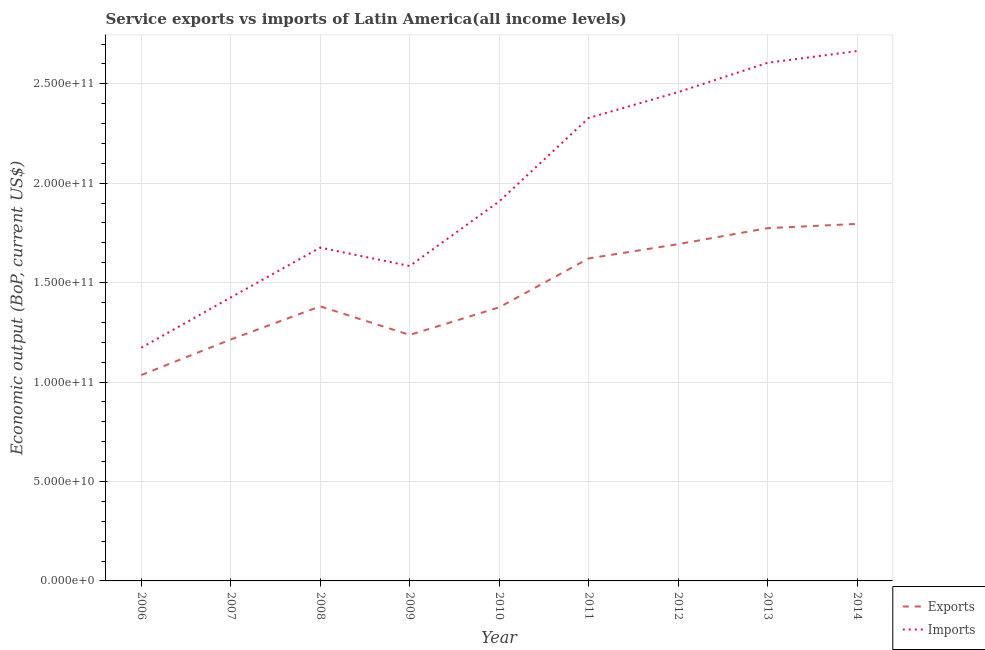Does the line corresponding to amount of service imports intersect with the line corresponding to amount of service exports?
Make the answer very short. No. Is the number of lines equal to the number of legend labels?
Provide a short and direct response. Yes. What is the amount of service imports in 2008?
Your answer should be compact. 1.68e+11. Across all years, what is the maximum amount of service exports?
Make the answer very short. 1.80e+11. Across all years, what is the minimum amount of service exports?
Give a very brief answer. 1.04e+11. In which year was the amount of service exports minimum?
Ensure brevity in your answer.  2006. What is the total amount of service imports in the graph?
Your answer should be very brief. 1.78e+12. What is the difference between the amount of service exports in 2010 and that in 2013?
Make the answer very short. -3.98e+1. What is the difference between the amount of service imports in 2010 and the amount of service exports in 2007?
Give a very brief answer. 6.94e+1. What is the average amount of service exports per year?
Offer a very short reply. 1.46e+11. In the year 2014, what is the difference between the amount of service imports and amount of service exports?
Offer a terse response. 8.69e+1. What is the ratio of the amount of service imports in 2009 to that in 2014?
Your answer should be very brief. 0.59. Is the difference between the amount of service exports in 2009 and 2010 greater than the difference between the amount of service imports in 2009 and 2010?
Provide a short and direct response. Yes. What is the difference between the highest and the second highest amount of service imports?
Your response must be concise. 5.91e+09. What is the difference between the highest and the lowest amount of service exports?
Keep it short and to the point. 7.60e+1. Is the sum of the amount of service imports in 2008 and 2012 greater than the maximum amount of service exports across all years?
Ensure brevity in your answer.  Yes. Does the amount of service imports monotonically increase over the years?
Give a very brief answer. No. How many lines are there?
Keep it short and to the point. 2. Does the graph contain any zero values?
Your answer should be compact. No. Does the graph contain grids?
Ensure brevity in your answer.  Yes. Where does the legend appear in the graph?
Keep it short and to the point. Bottom right. How many legend labels are there?
Provide a succinct answer. 2. What is the title of the graph?
Ensure brevity in your answer.  Service exports vs imports of Latin America(all income levels). What is the label or title of the X-axis?
Your answer should be compact. Year. What is the label or title of the Y-axis?
Keep it short and to the point. Economic output (BoP, current US$). What is the Economic output (BoP, current US$) in Exports in 2006?
Provide a short and direct response. 1.04e+11. What is the Economic output (BoP, current US$) in Imports in 2006?
Give a very brief answer. 1.17e+11. What is the Economic output (BoP, current US$) of Exports in 2007?
Keep it short and to the point. 1.21e+11. What is the Economic output (BoP, current US$) in Imports in 2007?
Your answer should be very brief. 1.43e+11. What is the Economic output (BoP, current US$) in Exports in 2008?
Ensure brevity in your answer.  1.38e+11. What is the Economic output (BoP, current US$) in Imports in 2008?
Provide a succinct answer. 1.68e+11. What is the Economic output (BoP, current US$) in Exports in 2009?
Provide a succinct answer. 1.24e+11. What is the Economic output (BoP, current US$) in Imports in 2009?
Give a very brief answer. 1.58e+11. What is the Economic output (BoP, current US$) of Exports in 2010?
Keep it short and to the point. 1.38e+11. What is the Economic output (BoP, current US$) of Imports in 2010?
Your response must be concise. 1.91e+11. What is the Economic output (BoP, current US$) in Exports in 2011?
Ensure brevity in your answer.  1.62e+11. What is the Economic output (BoP, current US$) in Imports in 2011?
Provide a short and direct response. 2.33e+11. What is the Economic output (BoP, current US$) of Exports in 2012?
Give a very brief answer. 1.69e+11. What is the Economic output (BoP, current US$) of Imports in 2012?
Offer a very short reply. 2.46e+11. What is the Economic output (BoP, current US$) in Exports in 2013?
Offer a very short reply. 1.77e+11. What is the Economic output (BoP, current US$) in Imports in 2013?
Your response must be concise. 2.61e+11. What is the Economic output (BoP, current US$) of Exports in 2014?
Provide a succinct answer. 1.80e+11. What is the Economic output (BoP, current US$) in Imports in 2014?
Give a very brief answer. 2.66e+11. Across all years, what is the maximum Economic output (BoP, current US$) of Exports?
Your answer should be compact. 1.80e+11. Across all years, what is the maximum Economic output (BoP, current US$) in Imports?
Provide a short and direct response. 2.66e+11. Across all years, what is the minimum Economic output (BoP, current US$) in Exports?
Make the answer very short. 1.04e+11. Across all years, what is the minimum Economic output (BoP, current US$) of Imports?
Ensure brevity in your answer.  1.17e+11. What is the total Economic output (BoP, current US$) in Exports in the graph?
Keep it short and to the point. 1.31e+12. What is the total Economic output (BoP, current US$) of Imports in the graph?
Give a very brief answer. 1.78e+12. What is the difference between the Economic output (BoP, current US$) of Exports in 2006 and that in 2007?
Make the answer very short. -1.79e+1. What is the difference between the Economic output (BoP, current US$) of Imports in 2006 and that in 2007?
Offer a terse response. -2.53e+1. What is the difference between the Economic output (BoP, current US$) in Exports in 2006 and that in 2008?
Provide a short and direct response. -3.45e+1. What is the difference between the Economic output (BoP, current US$) in Imports in 2006 and that in 2008?
Ensure brevity in your answer.  -5.04e+1. What is the difference between the Economic output (BoP, current US$) of Exports in 2006 and that in 2009?
Your answer should be compact. -2.02e+1. What is the difference between the Economic output (BoP, current US$) in Imports in 2006 and that in 2009?
Your answer should be very brief. -4.11e+1. What is the difference between the Economic output (BoP, current US$) in Exports in 2006 and that in 2010?
Offer a terse response. -3.40e+1. What is the difference between the Economic output (BoP, current US$) of Imports in 2006 and that in 2010?
Offer a very short reply. -7.36e+1. What is the difference between the Economic output (BoP, current US$) in Exports in 2006 and that in 2011?
Your response must be concise. -5.86e+1. What is the difference between the Economic output (BoP, current US$) of Imports in 2006 and that in 2011?
Offer a very short reply. -1.16e+11. What is the difference between the Economic output (BoP, current US$) of Exports in 2006 and that in 2012?
Your response must be concise. -6.58e+1. What is the difference between the Economic output (BoP, current US$) of Imports in 2006 and that in 2012?
Your answer should be compact. -1.29e+11. What is the difference between the Economic output (BoP, current US$) in Exports in 2006 and that in 2013?
Give a very brief answer. -7.39e+1. What is the difference between the Economic output (BoP, current US$) of Imports in 2006 and that in 2013?
Provide a succinct answer. -1.43e+11. What is the difference between the Economic output (BoP, current US$) in Exports in 2006 and that in 2014?
Keep it short and to the point. -7.60e+1. What is the difference between the Economic output (BoP, current US$) in Imports in 2006 and that in 2014?
Your response must be concise. -1.49e+11. What is the difference between the Economic output (BoP, current US$) of Exports in 2007 and that in 2008?
Provide a succinct answer. -1.67e+1. What is the difference between the Economic output (BoP, current US$) in Imports in 2007 and that in 2008?
Make the answer very short. -2.51e+1. What is the difference between the Economic output (BoP, current US$) of Exports in 2007 and that in 2009?
Your answer should be compact. -2.28e+09. What is the difference between the Economic output (BoP, current US$) of Imports in 2007 and that in 2009?
Your answer should be compact. -1.58e+1. What is the difference between the Economic output (BoP, current US$) in Exports in 2007 and that in 2010?
Keep it short and to the point. -1.62e+1. What is the difference between the Economic output (BoP, current US$) in Imports in 2007 and that in 2010?
Offer a terse response. -4.83e+1. What is the difference between the Economic output (BoP, current US$) in Exports in 2007 and that in 2011?
Provide a short and direct response. -4.07e+1. What is the difference between the Economic output (BoP, current US$) in Imports in 2007 and that in 2011?
Provide a short and direct response. -9.02e+1. What is the difference between the Economic output (BoP, current US$) of Exports in 2007 and that in 2012?
Offer a very short reply. -4.79e+1. What is the difference between the Economic output (BoP, current US$) of Imports in 2007 and that in 2012?
Provide a short and direct response. -1.03e+11. What is the difference between the Economic output (BoP, current US$) of Exports in 2007 and that in 2013?
Give a very brief answer. -5.60e+1. What is the difference between the Economic output (BoP, current US$) of Imports in 2007 and that in 2013?
Offer a terse response. -1.18e+11. What is the difference between the Economic output (BoP, current US$) in Exports in 2007 and that in 2014?
Offer a very short reply. -5.81e+1. What is the difference between the Economic output (BoP, current US$) in Imports in 2007 and that in 2014?
Offer a very short reply. -1.24e+11. What is the difference between the Economic output (BoP, current US$) of Exports in 2008 and that in 2009?
Your answer should be compact. 1.44e+1. What is the difference between the Economic output (BoP, current US$) of Imports in 2008 and that in 2009?
Give a very brief answer. 9.26e+09. What is the difference between the Economic output (BoP, current US$) of Exports in 2008 and that in 2010?
Give a very brief answer. 5.08e+08. What is the difference between the Economic output (BoP, current US$) in Imports in 2008 and that in 2010?
Keep it short and to the point. -2.32e+1. What is the difference between the Economic output (BoP, current US$) of Exports in 2008 and that in 2011?
Make the answer very short. -2.41e+1. What is the difference between the Economic output (BoP, current US$) in Imports in 2008 and that in 2011?
Provide a succinct answer. -6.52e+1. What is the difference between the Economic output (BoP, current US$) of Exports in 2008 and that in 2012?
Make the answer very short. -3.13e+1. What is the difference between the Economic output (BoP, current US$) in Imports in 2008 and that in 2012?
Provide a succinct answer. -7.82e+1. What is the difference between the Economic output (BoP, current US$) in Exports in 2008 and that in 2013?
Provide a short and direct response. -3.93e+1. What is the difference between the Economic output (BoP, current US$) in Imports in 2008 and that in 2013?
Offer a very short reply. -9.29e+1. What is the difference between the Economic output (BoP, current US$) in Exports in 2008 and that in 2014?
Keep it short and to the point. -4.14e+1. What is the difference between the Economic output (BoP, current US$) in Imports in 2008 and that in 2014?
Make the answer very short. -9.88e+1. What is the difference between the Economic output (BoP, current US$) in Exports in 2009 and that in 2010?
Make the answer very short. -1.39e+1. What is the difference between the Economic output (BoP, current US$) in Imports in 2009 and that in 2010?
Your answer should be very brief. -3.25e+1. What is the difference between the Economic output (BoP, current US$) in Exports in 2009 and that in 2011?
Your response must be concise. -3.85e+1. What is the difference between the Economic output (BoP, current US$) in Imports in 2009 and that in 2011?
Make the answer very short. -7.44e+1. What is the difference between the Economic output (BoP, current US$) in Exports in 2009 and that in 2012?
Provide a short and direct response. -4.56e+1. What is the difference between the Economic output (BoP, current US$) of Imports in 2009 and that in 2012?
Provide a succinct answer. -8.74e+1. What is the difference between the Economic output (BoP, current US$) in Exports in 2009 and that in 2013?
Provide a succinct answer. -5.37e+1. What is the difference between the Economic output (BoP, current US$) in Imports in 2009 and that in 2013?
Offer a very short reply. -1.02e+11. What is the difference between the Economic output (BoP, current US$) of Exports in 2009 and that in 2014?
Keep it short and to the point. -5.58e+1. What is the difference between the Economic output (BoP, current US$) of Imports in 2009 and that in 2014?
Ensure brevity in your answer.  -1.08e+11. What is the difference between the Economic output (BoP, current US$) in Exports in 2010 and that in 2011?
Ensure brevity in your answer.  -2.46e+1. What is the difference between the Economic output (BoP, current US$) of Imports in 2010 and that in 2011?
Make the answer very short. -4.20e+1. What is the difference between the Economic output (BoP, current US$) in Exports in 2010 and that in 2012?
Offer a terse response. -3.18e+1. What is the difference between the Economic output (BoP, current US$) in Imports in 2010 and that in 2012?
Your answer should be very brief. -5.50e+1. What is the difference between the Economic output (BoP, current US$) in Exports in 2010 and that in 2013?
Keep it short and to the point. -3.98e+1. What is the difference between the Economic output (BoP, current US$) in Imports in 2010 and that in 2013?
Your answer should be very brief. -6.97e+1. What is the difference between the Economic output (BoP, current US$) of Exports in 2010 and that in 2014?
Provide a succinct answer. -4.20e+1. What is the difference between the Economic output (BoP, current US$) in Imports in 2010 and that in 2014?
Provide a short and direct response. -7.56e+1. What is the difference between the Economic output (BoP, current US$) of Exports in 2011 and that in 2012?
Provide a short and direct response. -7.18e+09. What is the difference between the Economic output (BoP, current US$) in Imports in 2011 and that in 2012?
Ensure brevity in your answer.  -1.30e+1. What is the difference between the Economic output (BoP, current US$) in Exports in 2011 and that in 2013?
Ensure brevity in your answer.  -1.52e+1. What is the difference between the Economic output (BoP, current US$) in Imports in 2011 and that in 2013?
Ensure brevity in your answer.  -2.78e+1. What is the difference between the Economic output (BoP, current US$) in Exports in 2011 and that in 2014?
Give a very brief answer. -1.74e+1. What is the difference between the Economic output (BoP, current US$) in Imports in 2011 and that in 2014?
Offer a very short reply. -3.37e+1. What is the difference between the Economic output (BoP, current US$) in Exports in 2012 and that in 2013?
Give a very brief answer. -8.05e+09. What is the difference between the Economic output (BoP, current US$) in Imports in 2012 and that in 2013?
Provide a short and direct response. -1.47e+1. What is the difference between the Economic output (BoP, current US$) of Exports in 2012 and that in 2014?
Keep it short and to the point. -1.02e+1. What is the difference between the Economic output (BoP, current US$) in Imports in 2012 and that in 2014?
Ensure brevity in your answer.  -2.06e+1. What is the difference between the Economic output (BoP, current US$) of Exports in 2013 and that in 2014?
Provide a succinct answer. -2.14e+09. What is the difference between the Economic output (BoP, current US$) in Imports in 2013 and that in 2014?
Offer a terse response. -5.91e+09. What is the difference between the Economic output (BoP, current US$) in Exports in 2006 and the Economic output (BoP, current US$) in Imports in 2007?
Your answer should be very brief. -3.90e+1. What is the difference between the Economic output (BoP, current US$) of Exports in 2006 and the Economic output (BoP, current US$) of Imports in 2008?
Make the answer very short. -6.41e+1. What is the difference between the Economic output (BoP, current US$) of Exports in 2006 and the Economic output (BoP, current US$) of Imports in 2009?
Your answer should be very brief. -5.48e+1. What is the difference between the Economic output (BoP, current US$) in Exports in 2006 and the Economic output (BoP, current US$) in Imports in 2010?
Offer a very short reply. -8.73e+1. What is the difference between the Economic output (BoP, current US$) of Exports in 2006 and the Economic output (BoP, current US$) of Imports in 2011?
Your response must be concise. -1.29e+11. What is the difference between the Economic output (BoP, current US$) in Exports in 2006 and the Economic output (BoP, current US$) in Imports in 2012?
Keep it short and to the point. -1.42e+11. What is the difference between the Economic output (BoP, current US$) in Exports in 2006 and the Economic output (BoP, current US$) in Imports in 2013?
Provide a succinct answer. -1.57e+11. What is the difference between the Economic output (BoP, current US$) of Exports in 2006 and the Economic output (BoP, current US$) of Imports in 2014?
Offer a terse response. -1.63e+11. What is the difference between the Economic output (BoP, current US$) of Exports in 2007 and the Economic output (BoP, current US$) of Imports in 2008?
Keep it short and to the point. -4.62e+1. What is the difference between the Economic output (BoP, current US$) of Exports in 2007 and the Economic output (BoP, current US$) of Imports in 2009?
Give a very brief answer. -3.69e+1. What is the difference between the Economic output (BoP, current US$) of Exports in 2007 and the Economic output (BoP, current US$) of Imports in 2010?
Provide a succinct answer. -6.94e+1. What is the difference between the Economic output (BoP, current US$) in Exports in 2007 and the Economic output (BoP, current US$) in Imports in 2011?
Make the answer very short. -1.11e+11. What is the difference between the Economic output (BoP, current US$) of Exports in 2007 and the Economic output (BoP, current US$) of Imports in 2012?
Provide a succinct answer. -1.24e+11. What is the difference between the Economic output (BoP, current US$) in Exports in 2007 and the Economic output (BoP, current US$) in Imports in 2013?
Provide a succinct answer. -1.39e+11. What is the difference between the Economic output (BoP, current US$) of Exports in 2007 and the Economic output (BoP, current US$) of Imports in 2014?
Provide a succinct answer. -1.45e+11. What is the difference between the Economic output (BoP, current US$) in Exports in 2008 and the Economic output (BoP, current US$) in Imports in 2009?
Keep it short and to the point. -2.03e+1. What is the difference between the Economic output (BoP, current US$) in Exports in 2008 and the Economic output (BoP, current US$) in Imports in 2010?
Ensure brevity in your answer.  -5.27e+1. What is the difference between the Economic output (BoP, current US$) in Exports in 2008 and the Economic output (BoP, current US$) in Imports in 2011?
Give a very brief answer. -9.47e+1. What is the difference between the Economic output (BoP, current US$) of Exports in 2008 and the Economic output (BoP, current US$) of Imports in 2012?
Provide a succinct answer. -1.08e+11. What is the difference between the Economic output (BoP, current US$) in Exports in 2008 and the Economic output (BoP, current US$) in Imports in 2013?
Your answer should be compact. -1.22e+11. What is the difference between the Economic output (BoP, current US$) of Exports in 2008 and the Economic output (BoP, current US$) of Imports in 2014?
Keep it short and to the point. -1.28e+11. What is the difference between the Economic output (BoP, current US$) in Exports in 2009 and the Economic output (BoP, current US$) in Imports in 2010?
Your answer should be compact. -6.71e+1. What is the difference between the Economic output (BoP, current US$) of Exports in 2009 and the Economic output (BoP, current US$) of Imports in 2011?
Offer a terse response. -1.09e+11. What is the difference between the Economic output (BoP, current US$) of Exports in 2009 and the Economic output (BoP, current US$) of Imports in 2012?
Offer a terse response. -1.22e+11. What is the difference between the Economic output (BoP, current US$) of Exports in 2009 and the Economic output (BoP, current US$) of Imports in 2013?
Offer a very short reply. -1.37e+11. What is the difference between the Economic output (BoP, current US$) in Exports in 2009 and the Economic output (BoP, current US$) in Imports in 2014?
Keep it short and to the point. -1.43e+11. What is the difference between the Economic output (BoP, current US$) in Exports in 2010 and the Economic output (BoP, current US$) in Imports in 2011?
Your answer should be very brief. -9.52e+1. What is the difference between the Economic output (BoP, current US$) of Exports in 2010 and the Economic output (BoP, current US$) of Imports in 2012?
Provide a succinct answer. -1.08e+11. What is the difference between the Economic output (BoP, current US$) of Exports in 2010 and the Economic output (BoP, current US$) of Imports in 2013?
Your response must be concise. -1.23e+11. What is the difference between the Economic output (BoP, current US$) in Exports in 2010 and the Economic output (BoP, current US$) in Imports in 2014?
Your answer should be compact. -1.29e+11. What is the difference between the Economic output (BoP, current US$) of Exports in 2011 and the Economic output (BoP, current US$) of Imports in 2012?
Your answer should be very brief. -8.36e+1. What is the difference between the Economic output (BoP, current US$) in Exports in 2011 and the Economic output (BoP, current US$) in Imports in 2013?
Your answer should be compact. -9.84e+1. What is the difference between the Economic output (BoP, current US$) of Exports in 2011 and the Economic output (BoP, current US$) of Imports in 2014?
Make the answer very short. -1.04e+11. What is the difference between the Economic output (BoP, current US$) of Exports in 2012 and the Economic output (BoP, current US$) of Imports in 2013?
Your answer should be very brief. -9.12e+1. What is the difference between the Economic output (BoP, current US$) of Exports in 2012 and the Economic output (BoP, current US$) of Imports in 2014?
Your answer should be compact. -9.71e+1. What is the difference between the Economic output (BoP, current US$) of Exports in 2013 and the Economic output (BoP, current US$) of Imports in 2014?
Ensure brevity in your answer.  -8.91e+1. What is the average Economic output (BoP, current US$) in Exports per year?
Make the answer very short. 1.46e+11. What is the average Economic output (BoP, current US$) in Imports per year?
Give a very brief answer. 1.98e+11. In the year 2006, what is the difference between the Economic output (BoP, current US$) in Exports and Economic output (BoP, current US$) in Imports?
Keep it short and to the point. -1.37e+1. In the year 2007, what is the difference between the Economic output (BoP, current US$) of Exports and Economic output (BoP, current US$) of Imports?
Offer a terse response. -2.11e+1. In the year 2008, what is the difference between the Economic output (BoP, current US$) of Exports and Economic output (BoP, current US$) of Imports?
Make the answer very short. -2.95e+1. In the year 2009, what is the difference between the Economic output (BoP, current US$) of Exports and Economic output (BoP, current US$) of Imports?
Keep it short and to the point. -3.47e+1. In the year 2010, what is the difference between the Economic output (BoP, current US$) in Exports and Economic output (BoP, current US$) in Imports?
Provide a succinct answer. -5.33e+1. In the year 2011, what is the difference between the Economic output (BoP, current US$) of Exports and Economic output (BoP, current US$) of Imports?
Ensure brevity in your answer.  -7.06e+1. In the year 2012, what is the difference between the Economic output (BoP, current US$) in Exports and Economic output (BoP, current US$) in Imports?
Your answer should be compact. -7.65e+1. In the year 2013, what is the difference between the Economic output (BoP, current US$) in Exports and Economic output (BoP, current US$) in Imports?
Your answer should be very brief. -8.31e+1. In the year 2014, what is the difference between the Economic output (BoP, current US$) in Exports and Economic output (BoP, current US$) in Imports?
Offer a very short reply. -8.69e+1. What is the ratio of the Economic output (BoP, current US$) of Exports in 2006 to that in 2007?
Provide a succinct answer. 0.85. What is the ratio of the Economic output (BoP, current US$) in Imports in 2006 to that in 2007?
Make the answer very short. 0.82. What is the ratio of the Economic output (BoP, current US$) of Exports in 2006 to that in 2008?
Provide a short and direct response. 0.75. What is the ratio of the Economic output (BoP, current US$) of Imports in 2006 to that in 2008?
Give a very brief answer. 0.7. What is the ratio of the Economic output (BoP, current US$) in Exports in 2006 to that in 2009?
Give a very brief answer. 0.84. What is the ratio of the Economic output (BoP, current US$) in Imports in 2006 to that in 2009?
Your answer should be compact. 0.74. What is the ratio of the Economic output (BoP, current US$) in Exports in 2006 to that in 2010?
Your response must be concise. 0.75. What is the ratio of the Economic output (BoP, current US$) of Imports in 2006 to that in 2010?
Provide a succinct answer. 0.61. What is the ratio of the Economic output (BoP, current US$) in Exports in 2006 to that in 2011?
Offer a very short reply. 0.64. What is the ratio of the Economic output (BoP, current US$) in Imports in 2006 to that in 2011?
Provide a succinct answer. 0.5. What is the ratio of the Economic output (BoP, current US$) of Exports in 2006 to that in 2012?
Provide a short and direct response. 0.61. What is the ratio of the Economic output (BoP, current US$) in Imports in 2006 to that in 2012?
Your answer should be very brief. 0.48. What is the ratio of the Economic output (BoP, current US$) in Exports in 2006 to that in 2013?
Your response must be concise. 0.58. What is the ratio of the Economic output (BoP, current US$) in Imports in 2006 to that in 2013?
Offer a very short reply. 0.45. What is the ratio of the Economic output (BoP, current US$) of Exports in 2006 to that in 2014?
Keep it short and to the point. 0.58. What is the ratio of the Economic output (BoP, current US$) of Imports in 2006 to that in 2014?
Provide a short and direct response. 0.44. What is the ratio of the Economic output (BoP, current US$) in Exports in 2007 to that in 2008?
Keep it short and to the point. 0.88. What is the ratio of the Economic output (BoP, current US$) in Imports in 2007 to that in 2008?
Your answer should be very brief. 0.85. What is the ratio of the Economic output (BoP, current US$) of Exports in 2007 to that in 2009?
Provide a short and direct response. 0.98. What is the ratio of the Economic output (BoP, current US$) of Imports in 2007 to that in 2009?
Make the answer very short. 0.9. What is the ratio of the Economic output (BoP, current US$) of Exports in 2007 to that in 2010?
Offer a very short reply. 0.88. What is the ratio of the Economic output (BoP, current US$) of Imports in 2007 to that in 2010?
Your answer should be compact. 0.75. What is the ratio of the Economic output (BoP, current US$) in Exports in 2007 to that in 2011?
Provide a short and direct response. 0.75. What is the ratio of the Economic output (BoP, current US$) in Imports in 2007 to that in 2011?
Offer a terse response. 0.61. What is the ratio of the Economic output (BoP, current US$) of Exports in 2007 to that in 2012?
Give a very brief answer. 0.72. What is the ratio of the Economic output (BoP, current US$) of Imports in 2007 to that in 2012?
Keep it short and to the point. 0.58. What is the ratio of the Economic output (BoP, current US$) in Exports in 2007 to that in 2013?
Your response must be concise. 0.68. What is the ratio of the Economic output (BoP, current US$) in Imports in 2007 to that in 2013?
Your answer should be compact. 0.55. What is the ratio of the Economic output (BoP, current US$) of Exports in 2007 to that in 2014?
Give a very brief answer. 0.68. What is the ratio of the Economic output (BoP, current US$) in Imports in 2007 to that in 2014?
Offer a terse response. 0.54. What is the ratio of the Economic output (BoP, current US$) of Exports in 2008 to that in 2009?
Keep it short and to the point. 1.12. What is the ratio of the Economic output (BoP, current US$) of Imports in 2008 to that in 2009?
Your answer should be very brief. 1.06. What is the ratio of the Economic output (BoP, current US$) of Exports in 2008 to that in 2010?
Keep it short and to the point. 1. What is the ratio of the Economic output (BoP, current US$) of Imports in 2008 to that in 2010?
Give a very brief answer. 0.88. What is the ratio of the Economic output (BoP, current US$) of Exports in 2008 to that in 2011?
Provide a short and direct response. 0.85. What is the ratio of the Economic output (BoP, current US$) of Imports in 2008 to that in 2011?
Your answer should be compact. 0.72. What is the ratio of the Economic output (BoP, current US$) of Exports in 2008 to that in 2012?
Your answer should be compact. 0.82. What is the ratio of the Economic output (BoP, current US$) in Imports in 2008 to that in 2012?
Make the answer very short. 0.68. What is the ratio of the Economic output (BoP, current US$) in Exports in 2008 to that in 2013?
Provide a short and direct response. 0.78. What is the ratio of the Economic output (BoP, current US$) of Imports in 2008 to that in 2013?
Give a very brief answer. 0.64. What is the ratio of the Economic output (BoP, current US$) of Exports in 2008 to that in 2014?
Offer a terse response. 0.77. What is the ratio of the Economic output (BoP, current US$) in Imports in 2008 to that in 2014?
Offer a terse response. 0.63. What is the ratio of the Economic output (BoP, current US$) of Exports in 2009 to that in 2010?
Provide a short and direct response. 0.9. What is the ratio of the Economic output (BoP, current US$) of Imports in 2009 to that in 2010?
Your answer should be very brief. 0.83. What is the ratio of the Economic output (BoP, current US$) in Exports in 2009 to that in 2011?
Your answer should be compact. 0.76. What is the ratio of the Economic output (BoP, current US$) of Imports in 2009 to that in 2011?
Your response must be concise. 0.68. What is the ratio of the Economic output (BoP, current US$) of Exports in 2009 to that in 2012?
Offer a very short reply. 0.73. What is the ratio of the Economic output (BoP, current US$) of Imports in 2009 to that in 2012?
Provide a short and direct response. 0.64. What is the ratio of the Economic output (BoP, current US$) in Exports in 2009 to that in 2013?
Your answer should be compact. 0.7. What is the ratio of the Economic output (BoP, current US$) in Imports in 2009 to that in 2013?
Give a very brief answer. 0.61. What is the ratio of the Economic output (BoP, current US$) in Exports in 2009 to that in 2014?
Your answer should be very brief. 0.69. What is the ratio of the Economic output (BoP, current US$) of Imports in 2009 to that in 2014?
Make the answer very short. 0.59. What is the ratio of the Economic output (BoP, current US$) in Exports in 2010 to that in 2011?
Keep it short and to the point. 0.85. What is the ratio of the Economic output (BoP, current US$) in Imports in 2010 to that in 2011?
Make the answer very short. 0.82. What is the ratio of the Economic output (BoP, current US$) of Exports in 2010 to that in 2012?
Ensure brevity in your answer.  0.81. What is the ratio of the Economic output (BoP, current US$) in Imports in 2010 to that in 2012?
Your response must be concise. 0.78. What is the ratio of the Economic output (BoP, current US$) of Exports in 2010 to that in 2013?
Offer a very short reply. 0.78. What is the ratio of the Economic output (BoP, current US$) in Imports in 2010 to that in 2013?
Your response must be concise. 0.73. What is the ratio of the Economic output (BoP, current US$) in Exports in 2010 to that in 2014?
Provide a succinct answer. 0.77. What is the ratio of the Economic output (BoP, current US$) of Imports in 2010 to that in 2014?
Make the answer very short. 0.72. What is the ratio of the Economic output (BoP, current US$) of Exports in 2011 to that in 2012?
Your response must be concise. 0.96. What is the ratio of the Economic output (BoP, current US$) in Imports in 2011 to that in 2012?
Give a very brief answer. 0.95. What is the ratio of the Economic output (BoP, current US$) of Exports in 2011 to that in 2013?
Your answer should be very brief. 0.91. What is the ratio of the Economic output (BoP, current US$) of Imports in 2011 to that in 2013?
Your answer should be very brief. 0.89. What is the ratio of the Economic output (BoP, current US$) in Exports in 2011 to that in 2014?
Offer a terse response. 0.9. What is the ratio of the Economic output (BoP, current US$) in Imports in 2011 to that in 2014?
Offer a very short reply. 0.87. What is the ratio of the Economic output (BoP, current US$) of Exports in 2012 to that in 2013?
Offer a terse response. 0.95. What is the ratio of the Economic output (BoP, current US$) in Imports in 2012 to that in 2013?
Provide a succinct answer. 0.94. What is the ratio of the Economic output (BoP, current US$) of Exports in 2012 to that in 2014?
Your answer should be compact. 0.94. What is the ratio of the Economic output (BoP, current US$) of Imports in 2012 to that in 2014?
Give a very brief answer. 0.92. What is the ratio of the Economic output (BoP, current US$) in Exports in 2013 to that in 2014?
Ensure brevity in your answer.  0.99. What is the ratio of the Economic output (BoP, current US$) of Imports in 2013 to that in 2014?
Give a very brief answer. 0.98. What is the difference between the highest and the second highest Economic output (BoP, current US$) of Exports?
Provide a succinct answer. 2.14e+09. What is the difference between the highest and the second highest Economic output (BoP, current US$) in Imports?
Keep it short and to the point. 5.91e+09. What is the difference between the highest and the lowest Economic output (BoP, current US$) in Exports?
Provide a short and direct response. 7.60e+1. What is the difference between the highest and the lowest Economic output (BoP, current US$) of Imports?
Offer a very short reply. 1.49e+11. 